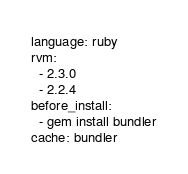<code> <loc_0><loc_0><loc_500><loc_500><_YAML_>language: ruby
rvm:
  - 2.3.0
  - 2.2.4
before_install:
  - gem install bundler
cache: bundler
</code> 